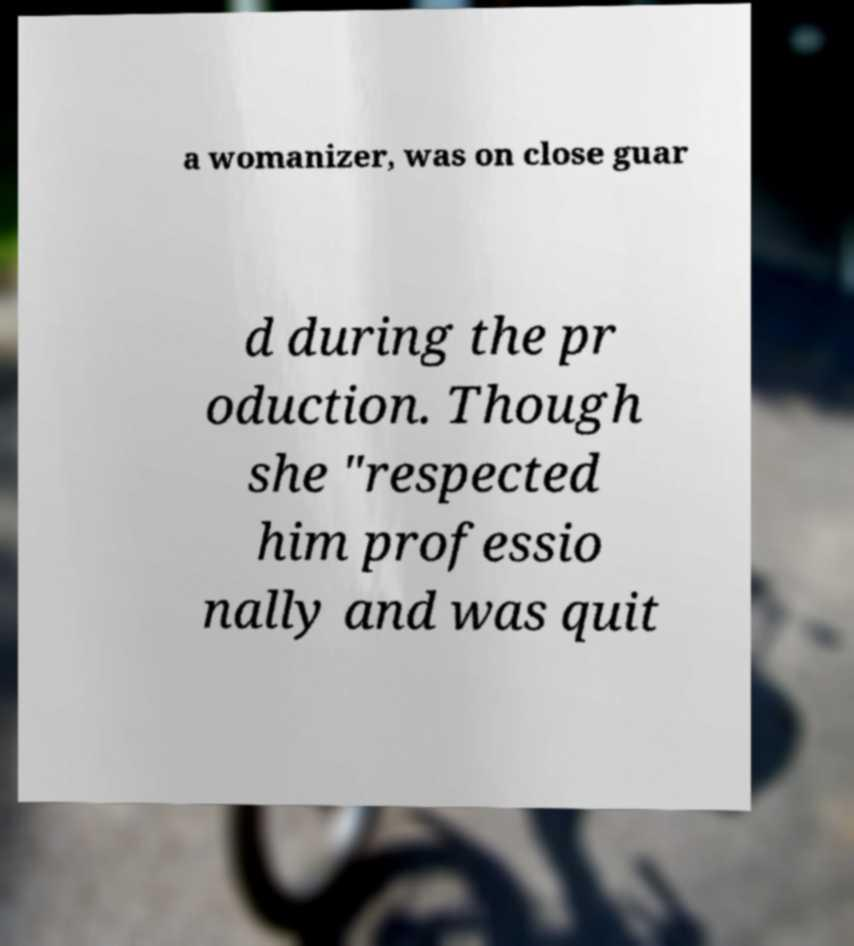For documentation purposes, I need the text within this image transcribed. Could you provide that? a womanizer, was on close guar d during the pr oduction. Though she "respected him professio nally and was quit 